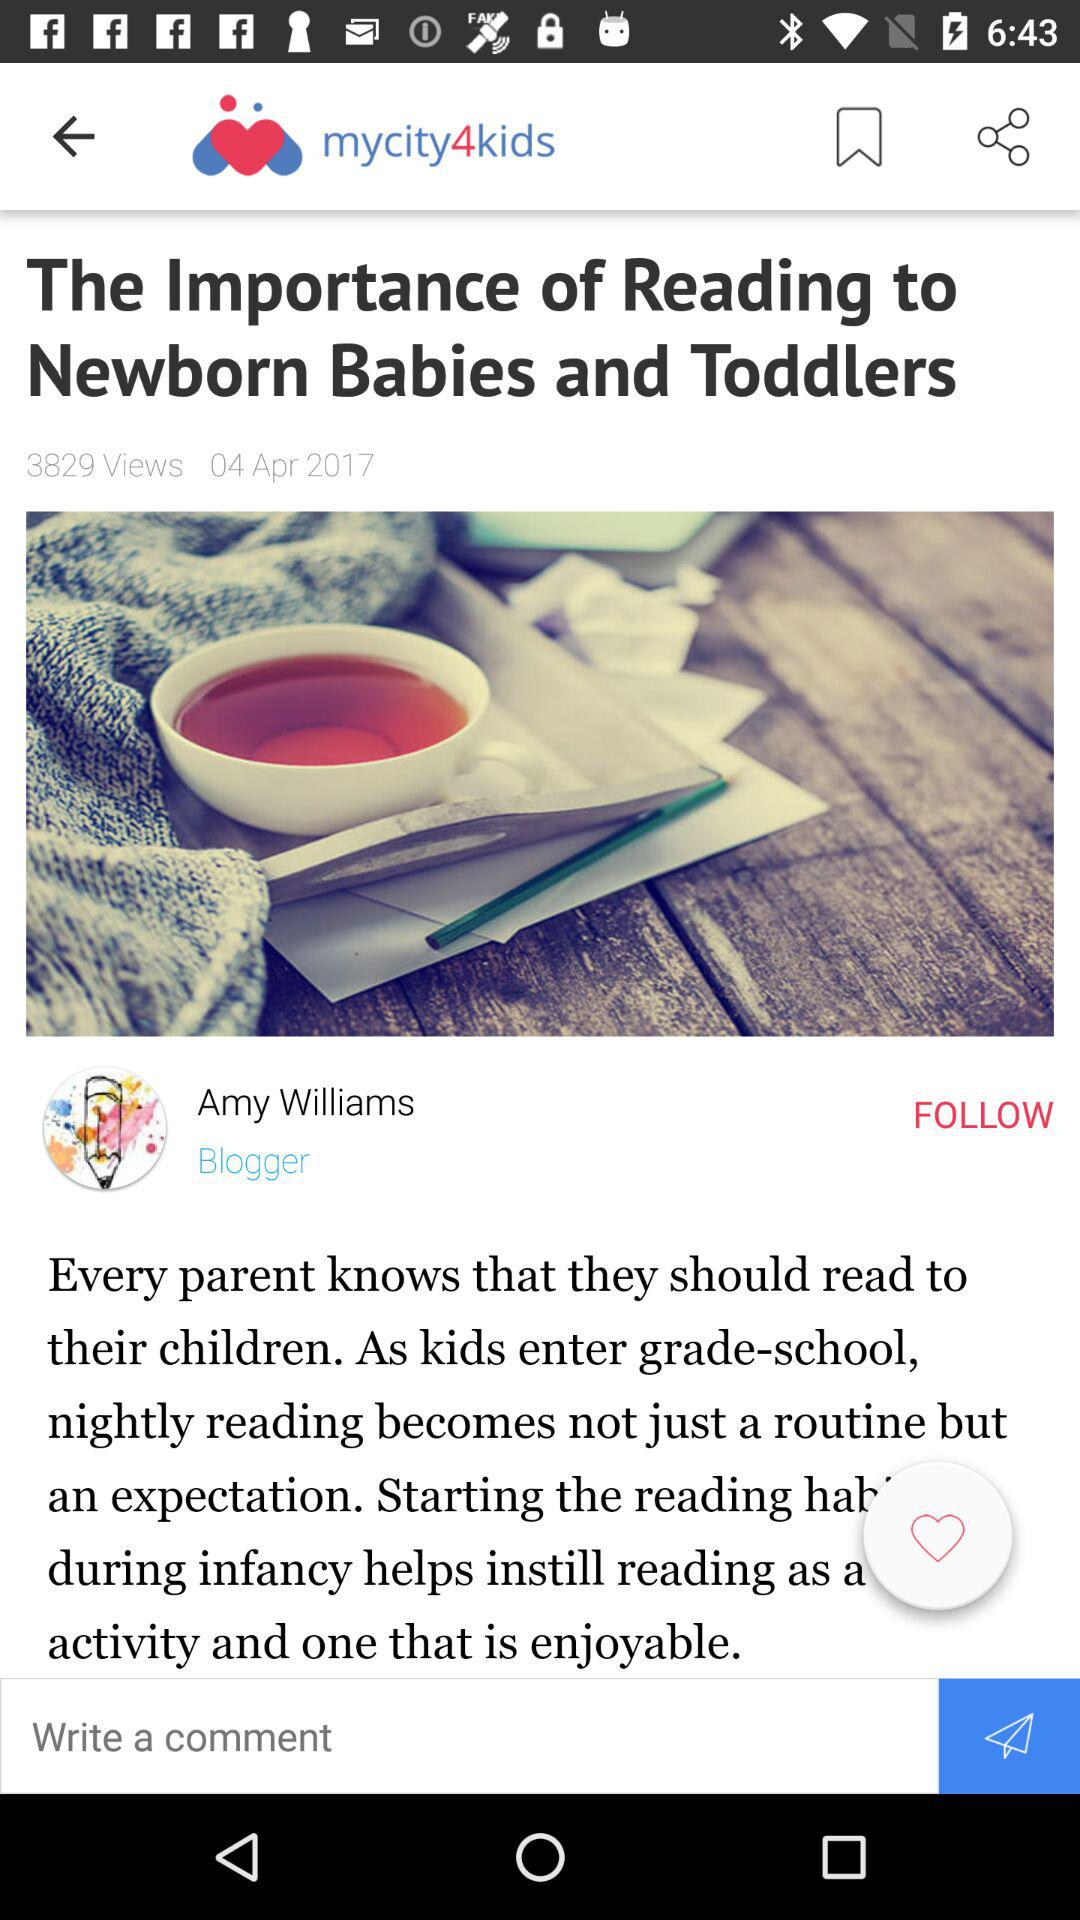What is the count of views? The count of views is 3829. 